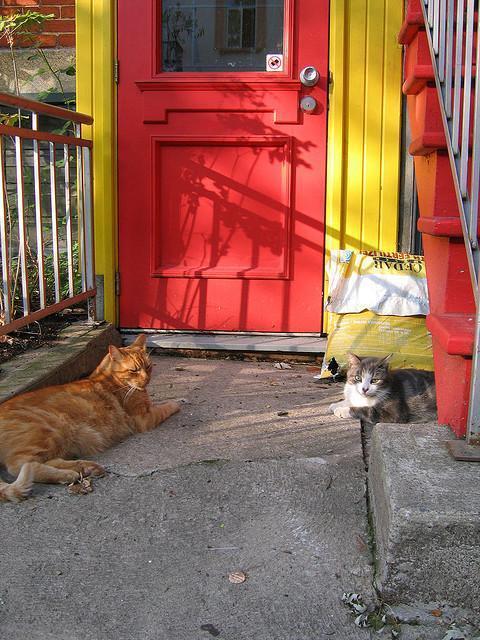How many cats are there?
Give a very brief answer. 2. How many people are shown?
Give a very brief answer. 0. 